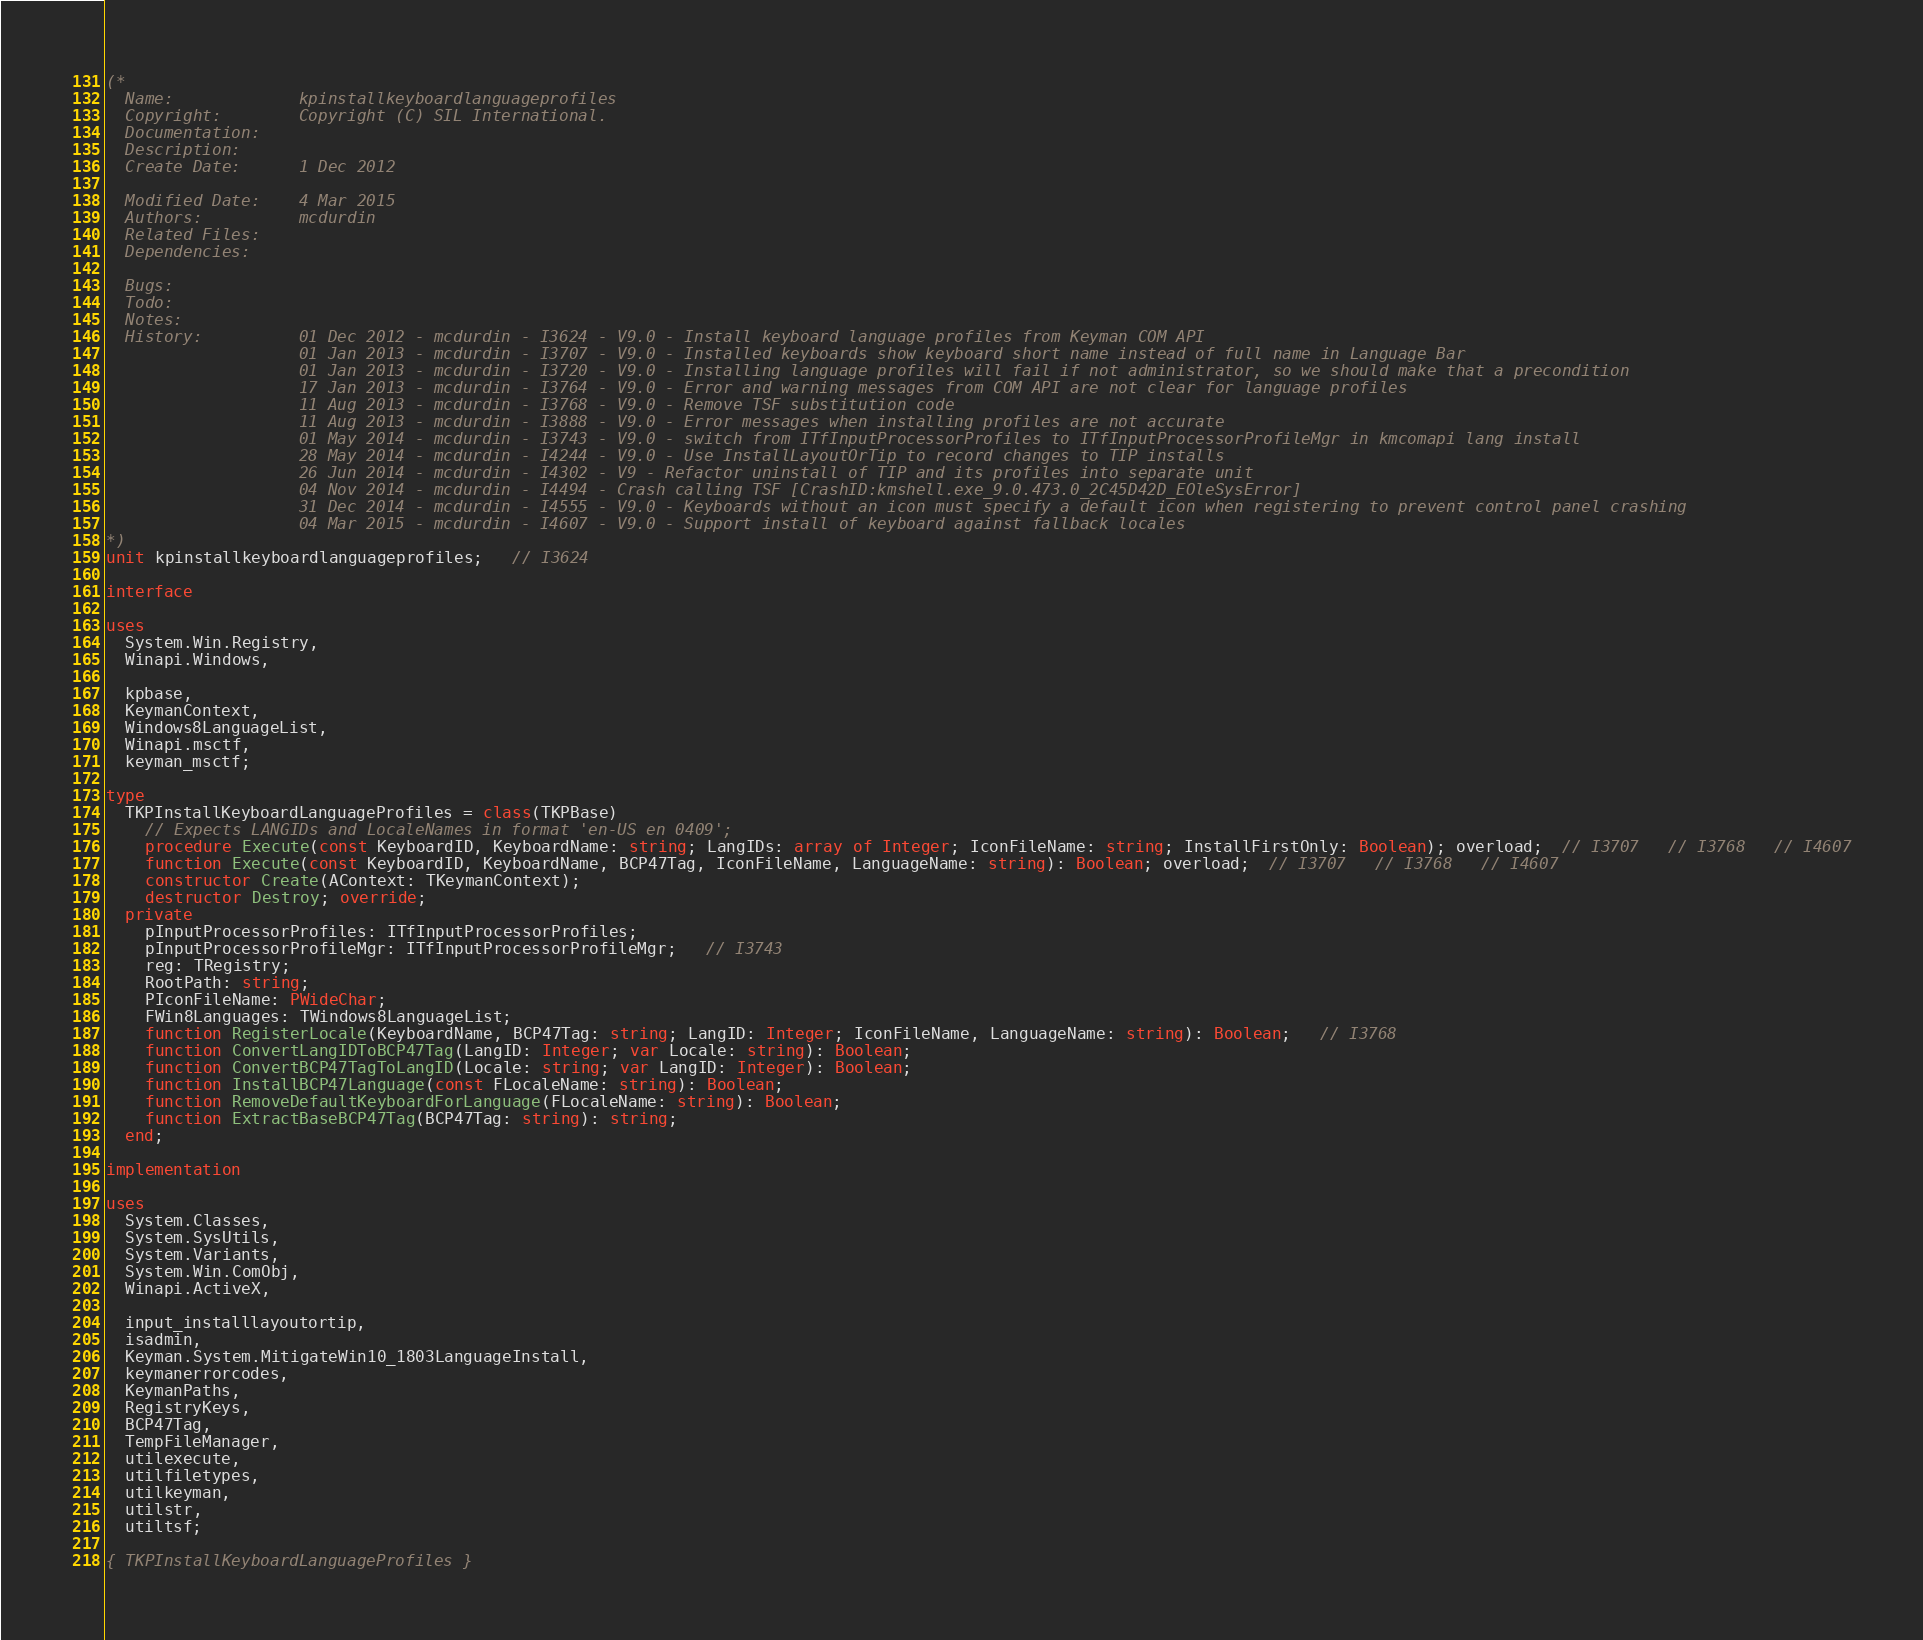Convert code to text. <code><loc_0><loc_0><loc_500><loc_500><_Pascal_>(*
  Name:             kpinstallkeyboardlanguageprofiles
  Copyright:        Copyright (C) SIL International.
  Documentation:
  Description:
  Create Date:      1 Dec 2012

  Modified Date:    4 Mar 2015
  Authors:          mcdurdin
  Related Files:
  Dependencies:

  Bugs:
  Todo:
  Notes:
  History:          01 Dec 2012 - mcdurdin - I3624 - V9.0 - Install keyboard language profiles from Keyman COM API
                    01 Jan 2013 - mcdurdin - I3707 - V9.0 - Installed keyboards show keyboard short name instead of full name in Language Bar
                    01 Jan 2013 - mcdurdin - I3720 - V9.0 - Installing language profiles will fail if not administrator, so we should make that a precondition
                    17 Jan 2013 - mcdurdin - I3764 - V9.0 - Error and warning messages from COM API are not clear for language profiles
                    11 Aug 2013 - mcdurdin - I3768 - V9.0 - Remove TSF substitution code
                    11 Aug 2013 - mcdurdin - I3888 - V9.0 - Error messages when installing profiles are not accurate
                    01 May 2014 - mcdurdin - I3743 - V9.0 - switch from ITfInputProcessorProfiles to ITfInputProcessorProfileMgr in kmcomapi lang install
                    28 May 2014 - mcdurdin - I4244 - V9.0 - Use InstallLayoutOrTip to record changes to TIP installs
                    26 Jun 2014 - mcdurdin - I4302 - V9 - Refactor uninstall of TIP and its profiles into separate unit
                    04 Nov 2014 - mcdurdin - I4494 - Crash calling TSF [CrashID:kmshell.exe_9.0.473.0_2C45D42D_EOleSysError]
                    31 Dec 2014 - mcdurdin - I4555 - V9.0 - Keyboards without an icon must specify a default icon when registering to prevent control panel crashing
                    04 Mar 2015 - mcdurdin - I4607 - V9.0 - Support install of keyboard against fallback locales
*)
unit kpinstallkeyboardlanguageprofiles;   // I3624

interface

uses
  System.Win.Registry,
  Winapi.Windows,

  kpbase,
  KeymanContext,
  Windows8LanguageList,
  Winapi.msctf,
  keyman_msctf;

type
  TKPInstallKeyboardLanguageProfiles = class(TKPBase)
    // Expects LANGIDs and LocaleNames in format 'en-US en 0409';
    procedure Execute(const KeyboardID, KeyboardName: string; LangIDs: array of Integer; IconFileName: string; InstallFirstOnly: Boolean); overload;  // I3707   // I3768   // I4607
    function Execute(const KeyboardID, KeyboardName, BCP47Tag, IconFileName, LanguageName: string): Boolean; overload;  // I3707   // I3768   // I4607
    constructor Create(AContext: TKeymanContext);
    destructor Destroy; override;
  private
    pInputProcessorProfiles: ITfInputProcessorProfiles;
    pInputProcessorProfileMgr: ITfInputProcessorProfileMgr;   // I3743
    reg: TRegistry;
    RootPath: string;
    PIconFileName: PWideChar;
    FWin8Languages: TWindows8LanguageList;
    function RegisterLocale(KeyboardName, BCP47Tag: string; LangID: Integer; IconFileName, LanguageName: string): Boolean;   // I3768
    function ConvertLangIDToBCP47Tag(LangID: Integer; var Locale: string): Boolean;
    function ConvertBCP47TagToLangID(Locale: string; var LangID: Integer): Boolean;
    function InstallBCP47Language(const FLocaleName: string): Boolean;
    function RemoveDefaultKeyboardForLanguage(FLocaleName: string): Boolean;
    function ExtractBaseBCP47Tag(BCP47Tag: string): string;
  end;

implementation

uses
  System.Classes,
  System.SysUtils,
  System.Variants,
  System.Win.ComObj,
  Winapi.ActiveX,

  input_installlayoutortip,
  isadmin,
  Keyman.System.MitigateWin10_1803LanguageInstall,
  keymanerrorcodes,
  KeymanPaths,
  RegistryKeys,
  BCP47Tag,
  TempFileManager,
  utilexecute,
  utilfiletypes,
  utilkeyman,
  utilstr,
  utiltsf;

{ TKPInstallKeyboardLanguageProfiles }
</code> 